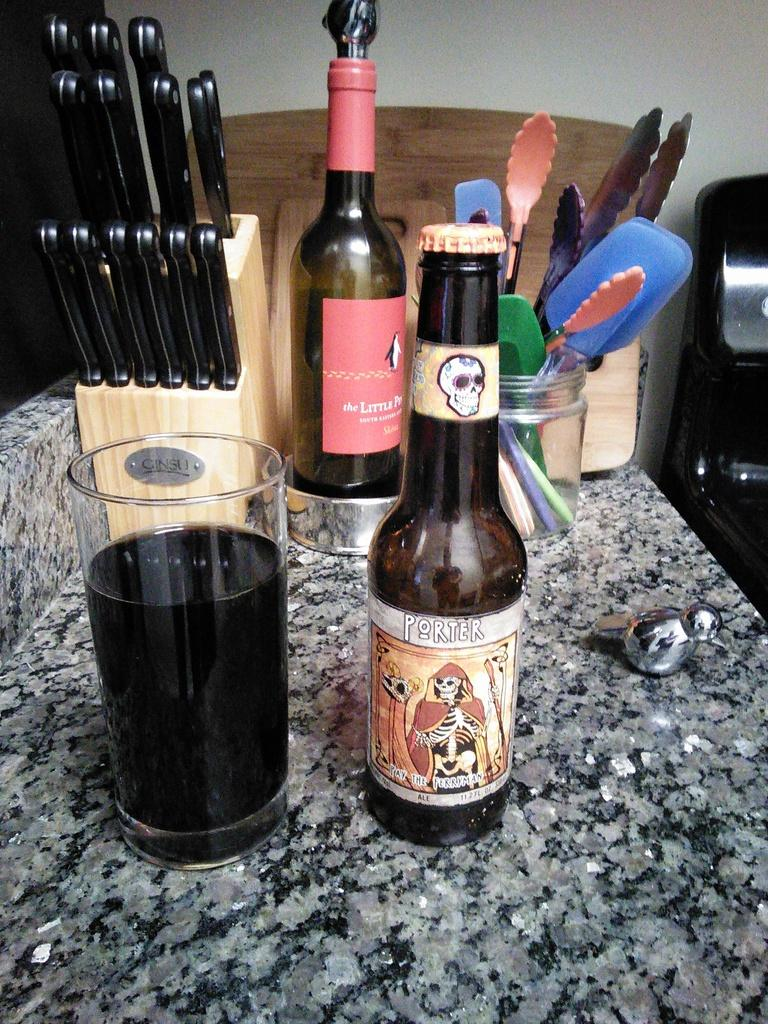What piece of furniture is present in the image? There is a table in the image. What items can be seen on the table? There are bottles, a group of knives, spoons, and a glass of drink on the table. How many types of utensils are visible on the table? There are two types of utensils visible on the table: knives and spoons. Can you describe the development of the sky in the image? There is no sky present in the image, as it is focused on a table with various items on it. 